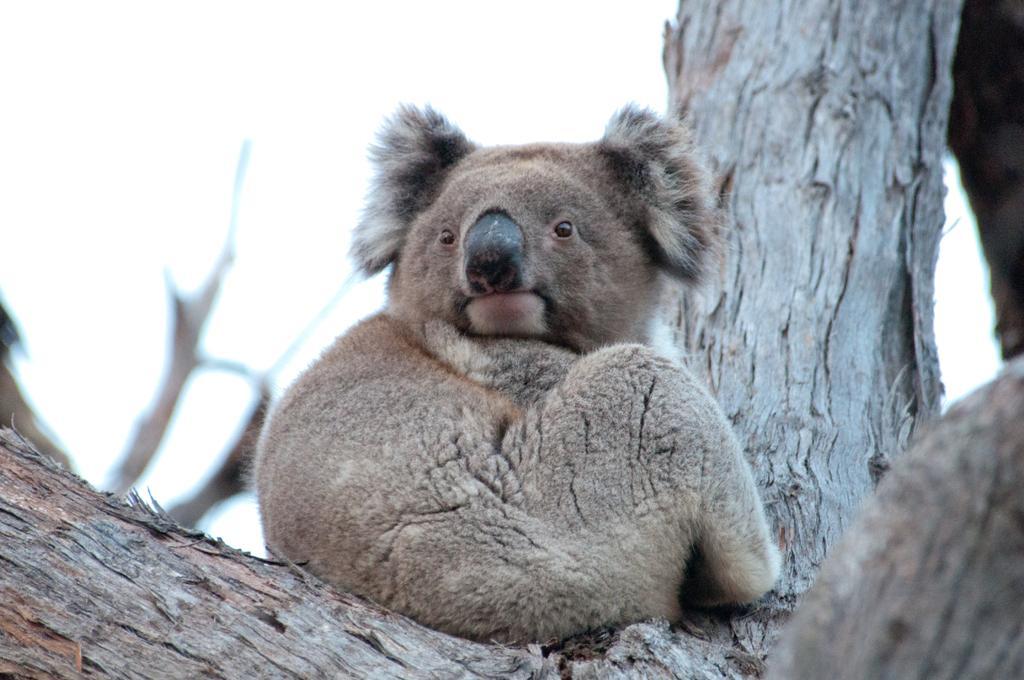Describe this image in one or two sentences. In this picture I can see there is a koala sitting on the tree and in the backdrop I can see the sky is clear. 